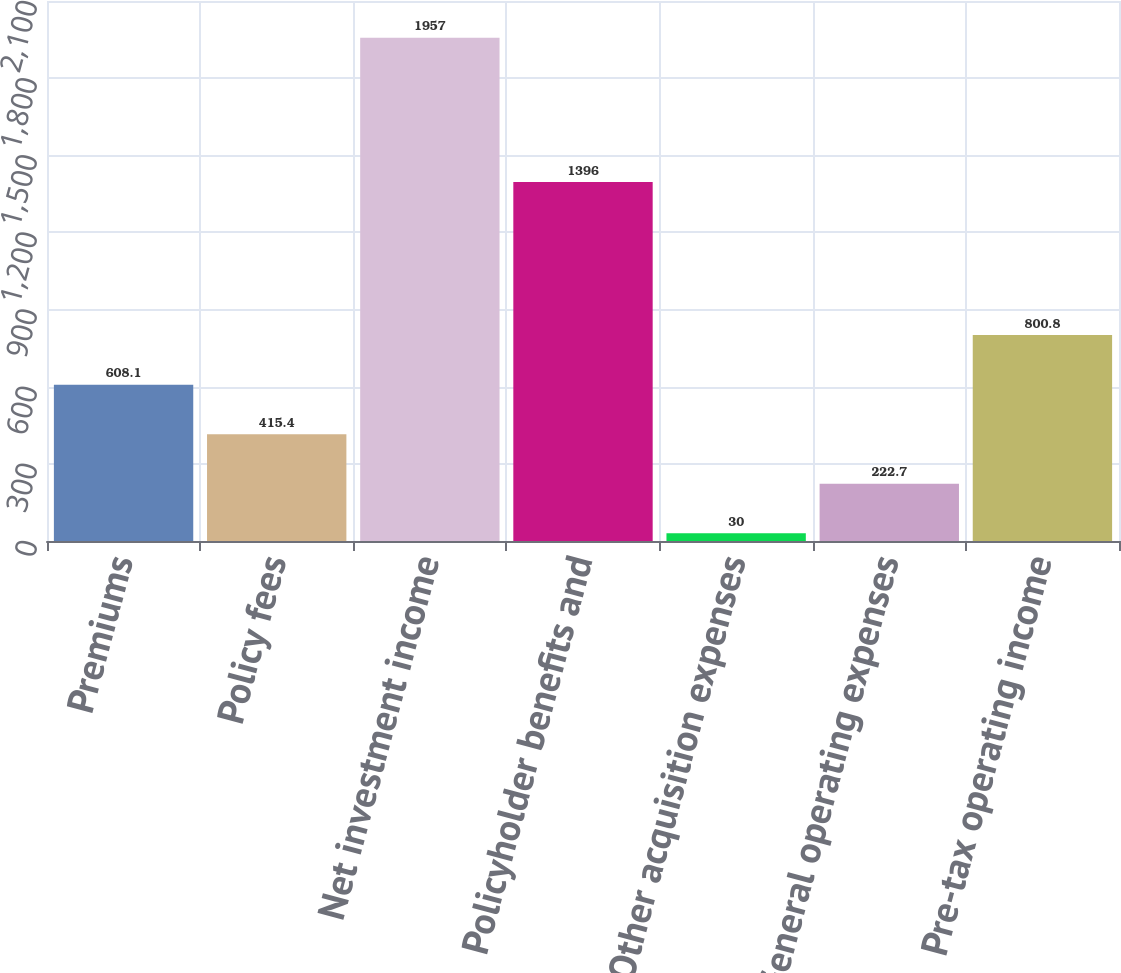Convert chart. <chart><loc_0><loc_0><loc_500><loc_500><bar_chart><fcel>Premiums<fcel>Policy fees<fcel>Net investment income<fcel>Policyholder benefits and<fcel>Other acquisition expenses<fcel>General operating expenses<fcel>Pre-tax operating income<nl><fcel>608.1<fcel>415.4<fcel>1957<fcel>1396<fcel>30<fcel>222.7<fcel>800.8<nl></chart> 